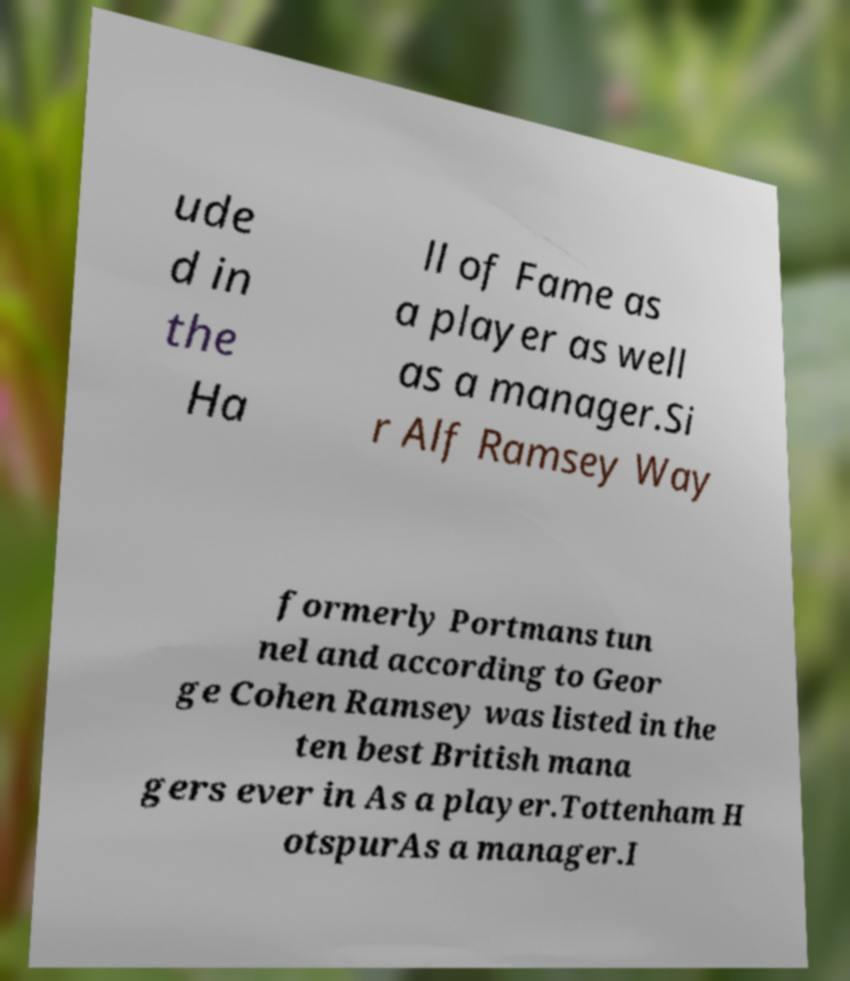Please read and relay the text visible in this image. What does it say? ude d in the Ha ll of Fame as a player as well as a manager.Si r Alf Ramsey Way formerly Portmans tun nel and according to Geor ge Cohen Ramsey was listed in the ten best British mana gers ever in As a player.Tottenham H otspurAs a manager.I 